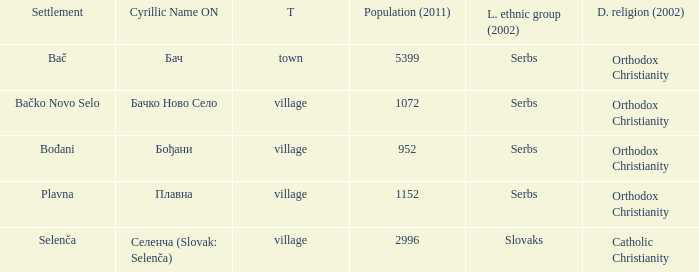How to you write  плавна with the latin alphabet? Plavna. 